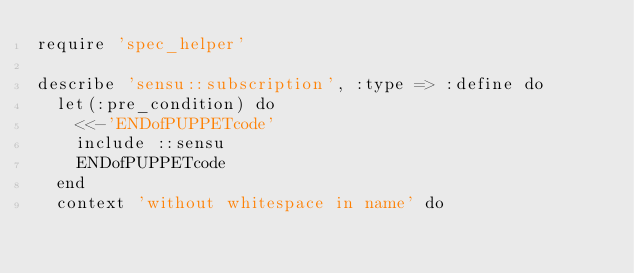<code> <loc_0><loc_0><loc_500><loc_500><_Ruby_>require 'spec_helper'

describe 'sensu::subscription', :type => :define do
  let(:pre_condition) do
    <<-'ENDofPUPPETcode'
    include ::sensu
    ENDofPUPPETcode
  end
  context 'without whitespace in name' do</code> 